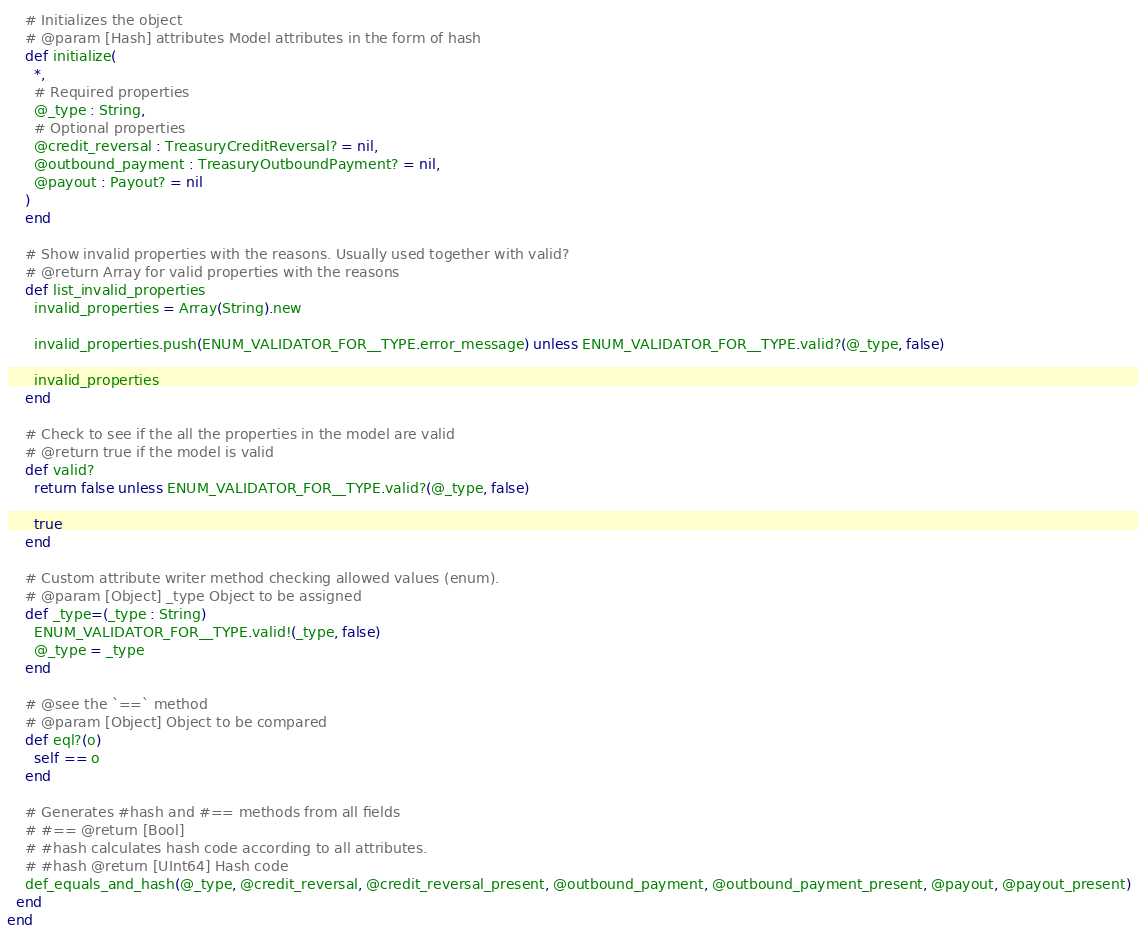<code> <loc_0><loc_0><loc_500><loc_500><_Crystal_>
    # Initializes the object
    # @param [Hash] attributes Model attributes in the form of hash
    def initialize(
      *,
      # Required properties
      @_type : String,
      # Optional properties
      @credit_reversal : TreasuryCreditReversal? = nil,
      @outbound_payment : TreasuryOutboundPayment? = nil,
      @payout : Payout? = nil
    )
    end

    # Show invalid properties with the reasons. Usually used together with valid?
    # @return Array for valid properties with the reasons
    def list_invalid_properties
      invalid_properties = Array(String).new

      invalid_properties.push(ENUM_VALIDATOR_FOR__TYPE.error_message) unless ENUM_VALIDATOR_FOR__TYPE.valid?(@_type, false)

      invalid_properties
    end

    # Check to see if the all the properties in the model are valid
    # @return true if the model is valid
    def valid?
      return false unless ENUM_VALIDATOR_FOR__TYPE.valid?(@_type, false)

      true
    end

    # Custom attribute writer method checking allowed values (enum).
    # @param [Object] _type Object to be assigned
    def _type=(_type : String)
      ENUM_VALIDATOR_FOR__TYPE.valid!(_type, false)
      @_type = _type
    end

    # @see the `==` method
    # @param [Object] Object to be compared
    def eql?(o)
      self == o
    end

    # Generates #hash and #== methods from all fields
    # #== @return [Bool]
    # #hash calculates hash code according to all attributes.
    # #hash @return [UInt64] Hash code
    def_equals_and_hash(@_type, @credit_reversal, @credit_reversal_present, @outbound_payment, @outbound_payment_present, @payout, @payout_present)
  end
end
</code> 